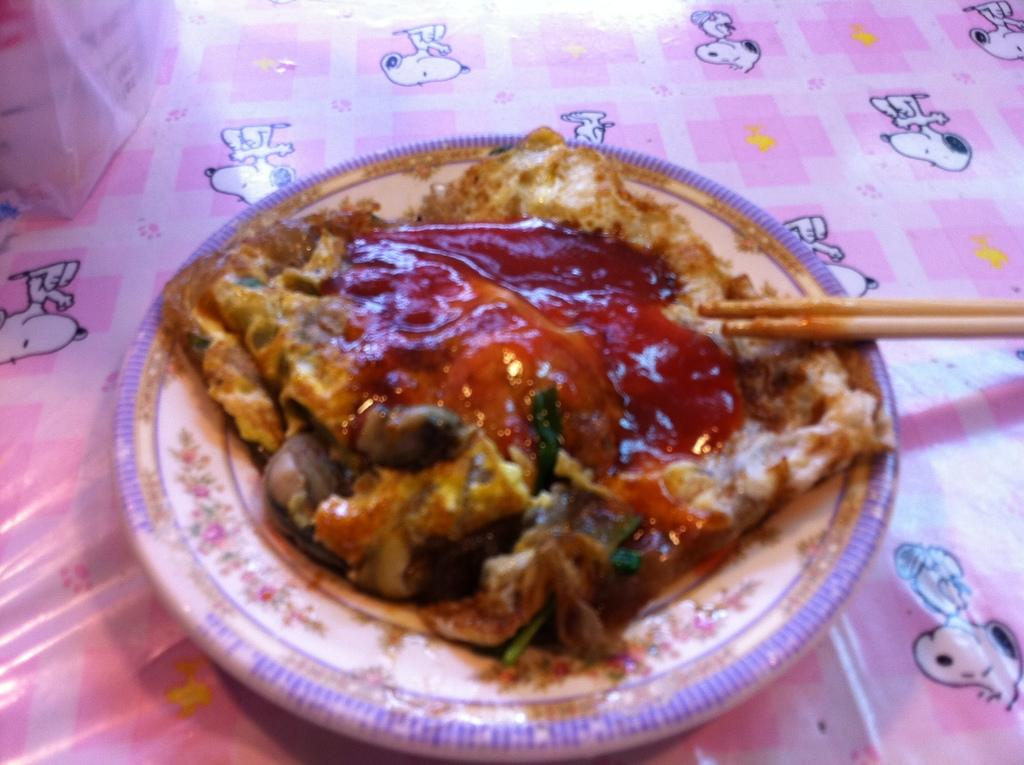What type of food item is visible in the image? There is a food item with jam on it in the image. Where is the food item placed? The food item is on a plate. What utensil is present on the right side of the image? There are chopsticks on the right side of the image. What is the color and design of the cover in the image? The cover is pink and has dog images on it. What interests does the dad have in the image? There is no dad present in the image, so it is not possible to determine their interests. 